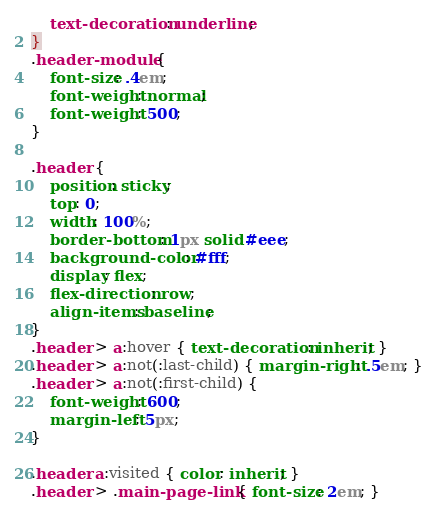<code> <loc_0><loc_0><loc_500><loc_500><_CSS_>    text-decoration: underline;
}
.header-module {
    font-size: .4em;
    font-weight: normal;
    font-weight: 500;
}

.header {
    position: sticky;
    top: 0;
    width: 100%;
    border-bottom: 1px solid #eee;
    background-color: #fff;
    display: flex;
    flex-direction: row;
    align-items: baseline;
}
.header > a:hover { text-decoration: inherit; }
.header > a:not(:last-child) { margin-right: .5em; }
.header > a:not(:first-child) {
    font-weight: 600;
    margin-left: 5px;
}

.header a:visited { color: inherit; }
.header > .main-page-link { font-size: 2em; }

</code> 